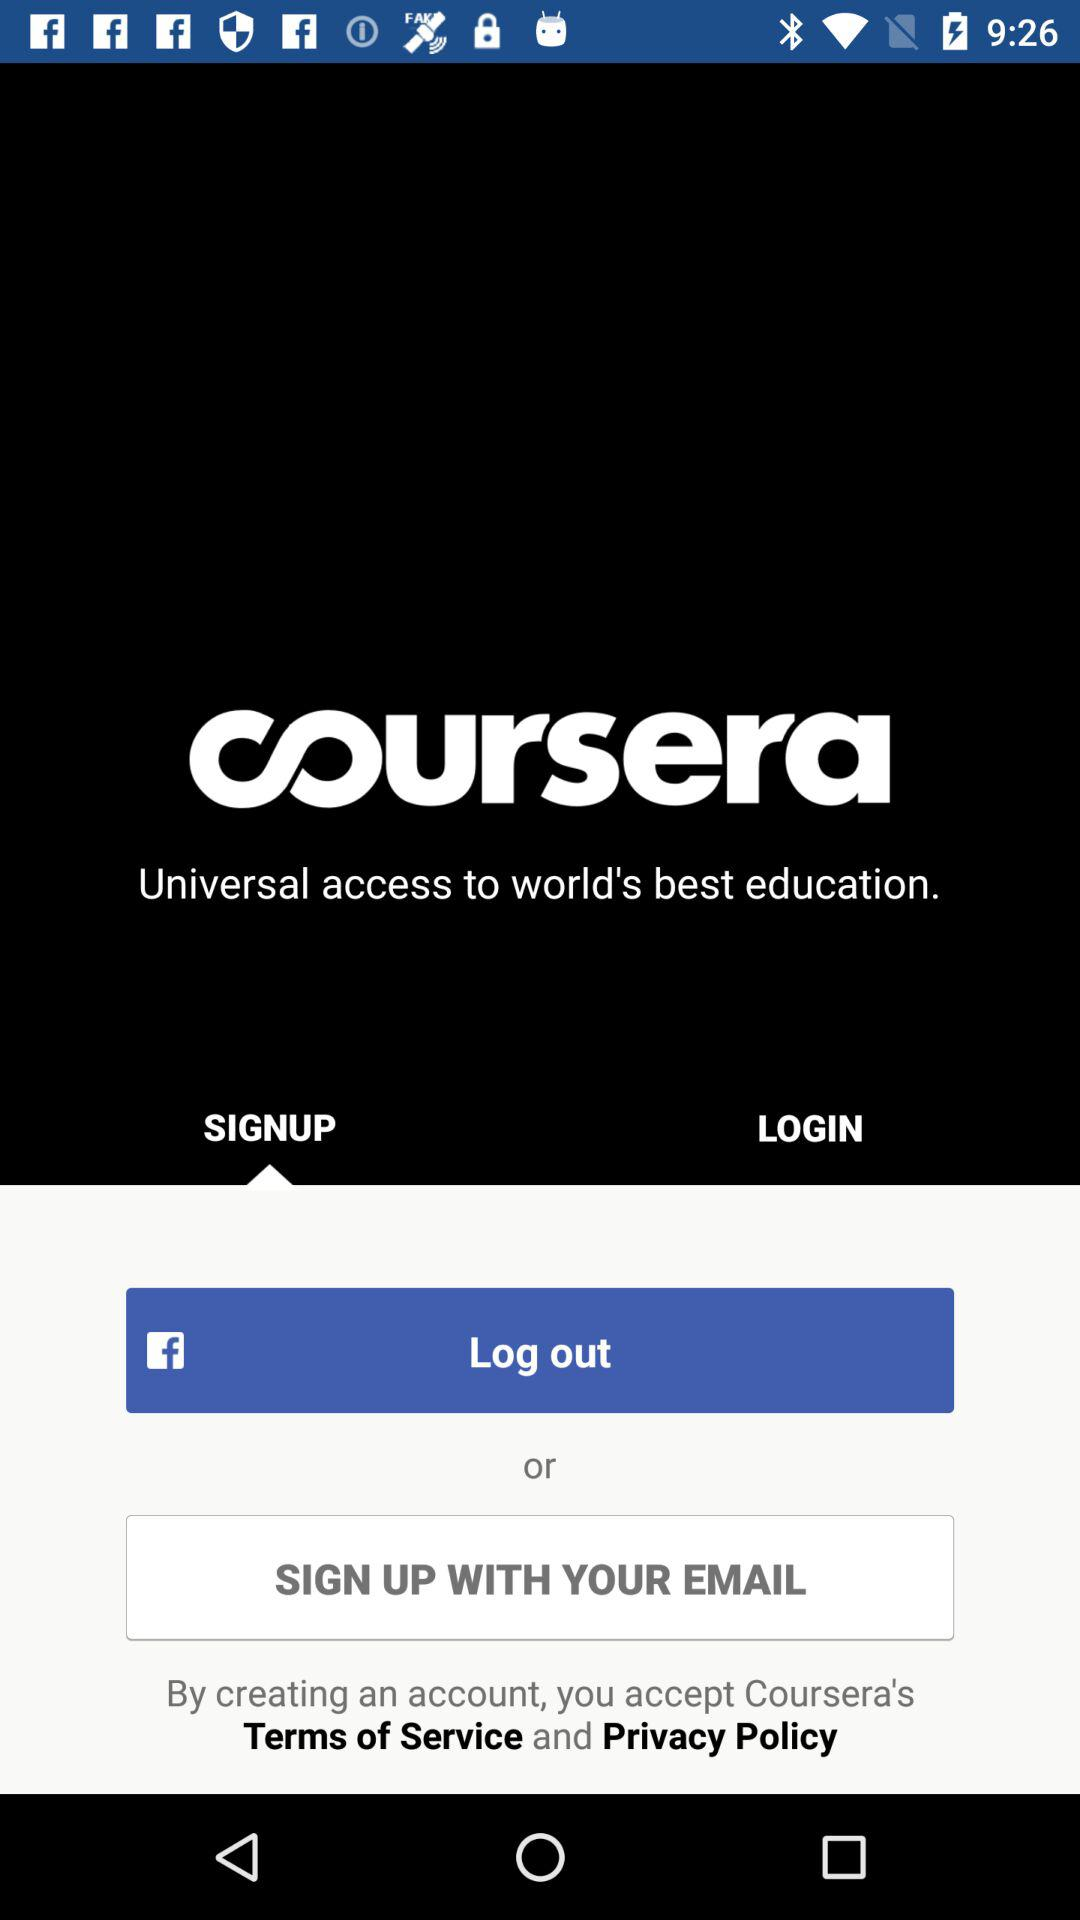How much does "coursera" cost?
When the provided information is insufficient, respond with <no answer>. <no answer> 